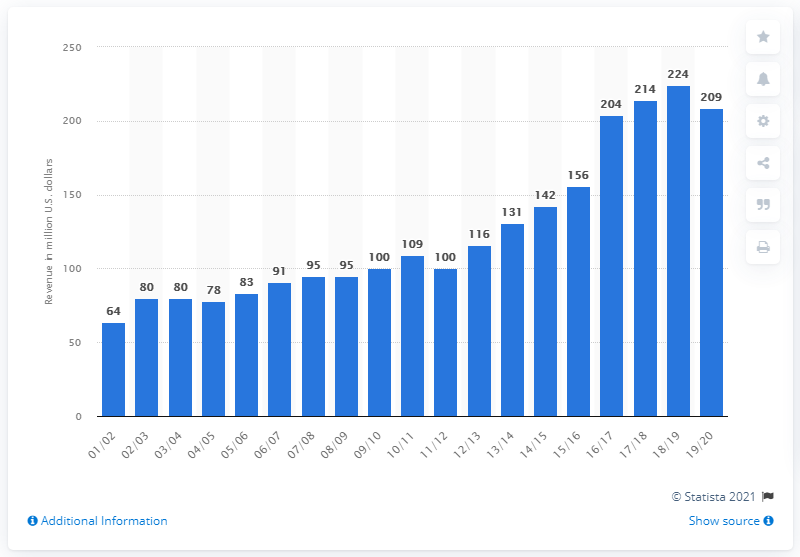Outline some significant characteristics in this image. The estimated revenue of the New Orleans Pelicans for the 2019/2020 fiscal year was approximately 209 million dollars. 